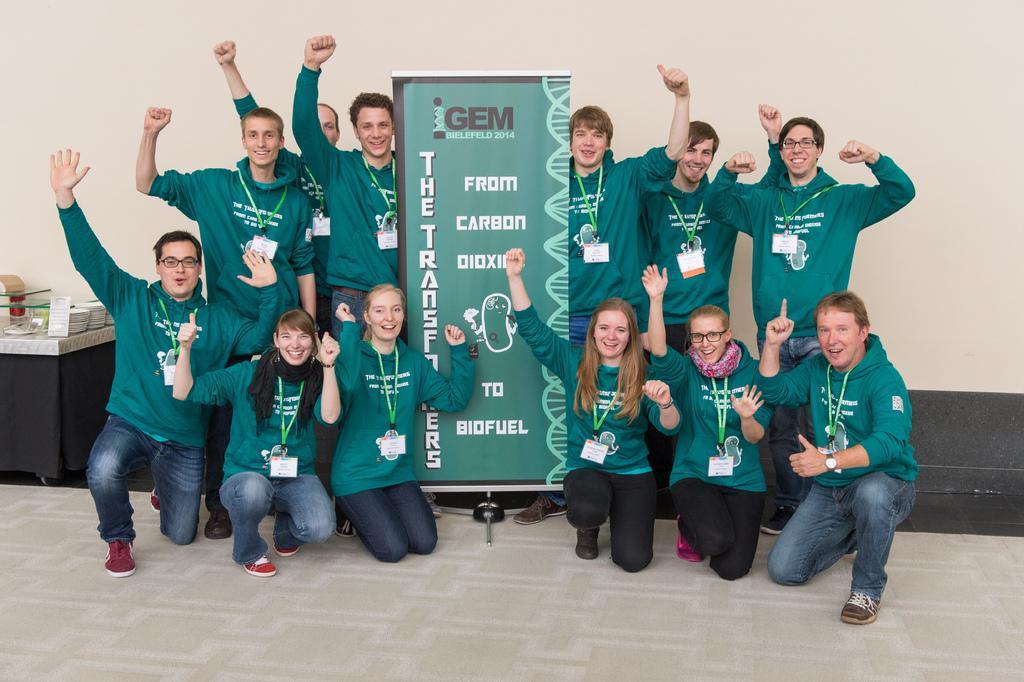Could you give a brief overview of what you see in this image? In this image there are persons kneeling and standing and smiling and holding a banner with some text written on it. On the left side there is a table, on the table there are objects which are white and brown in colour. 